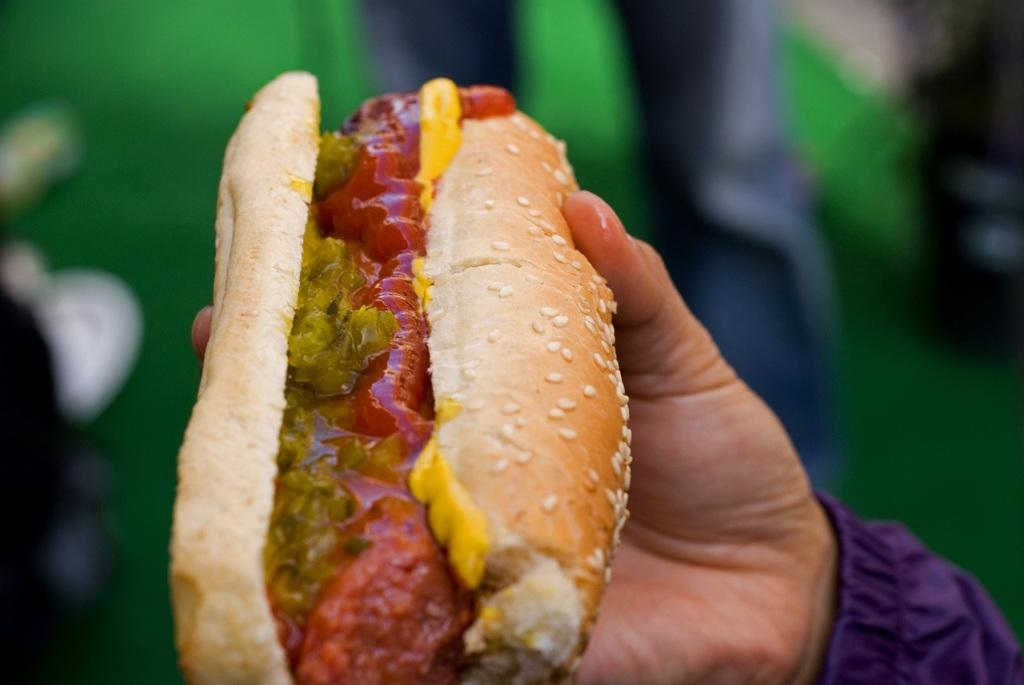What is the main subject of the image? The main subject of the image is a human hand. What is the hand holding in the image? The hand is holding a stuffed hot dog. What type of collar is visible on the stuffed hot dog in the image? There is no collar present on the stuffed hot dog in the image. 